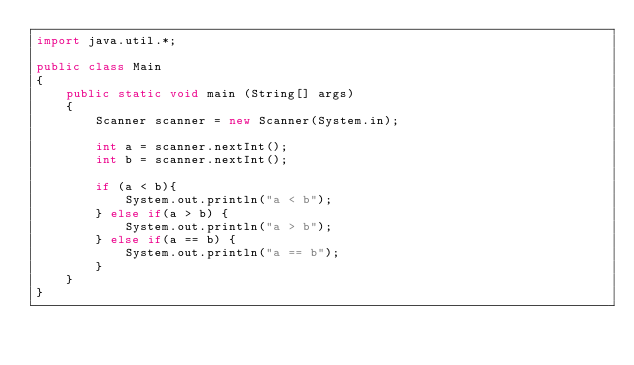Convert code to text. <code><loc_0><loc_0><loc_500><loc_500><_Java_>import java.util.*;

public class Main
{
    public static void main (String[] args)
    {
        Scanner scanner = new Scanner(System.in);

        int a = scanner.nextInt();
        int b = scanner.nextInt();

        if (a < b){
            System.out.println("a < b");
        } else if(a > b) {
            System.out.println("a > b");
        } else if(a == b) {
            System.out.println("a == b");
        }
    }
}</code> 